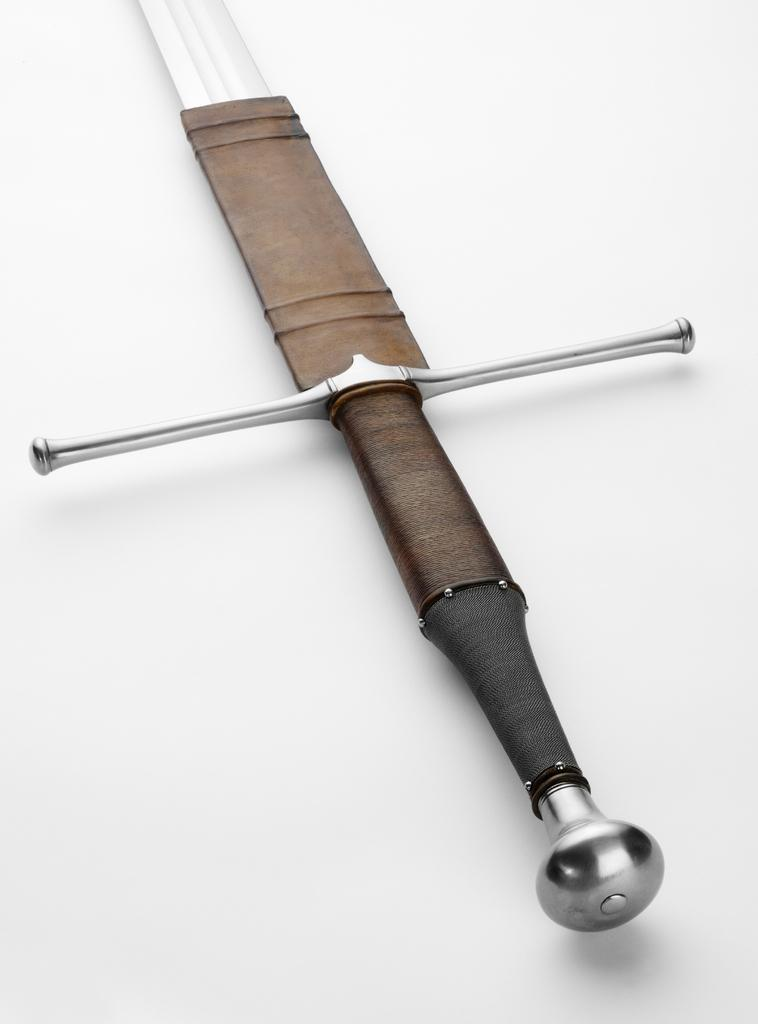What object can be seen in the image? There is a sword in the image. What color is the background of the image? The background of the image is white. What type of winter clothing is being worn by the sword in the image? There is no winter clothing present in the image, as the subject is a sword and not a person. 